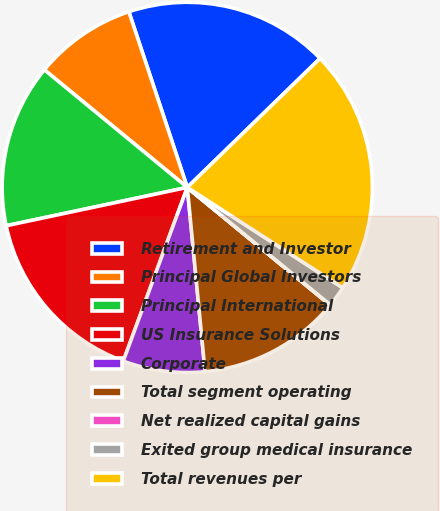<chart> <loc_0><loc_0><loc_500><loc_500><pie_chart><fcel>Retirement and Investor<fcel>Principal Global Investors<fcel>Principal International<fcel>US Insurance Solutions<fcel>Corporate<fcel>Total segment operating<fcel>Net realized capital gains<fcel>Exited group medical insurance<fcel>Total revenues per<nl><fcel>17.84%<fcel>8.93%<fcel>14.28%<fcel>16.06%<fcel>7.15%<fcel>12.5%<fcel>0.03%<fcel>1.81%<fcel>21.4%<nl></chart> 